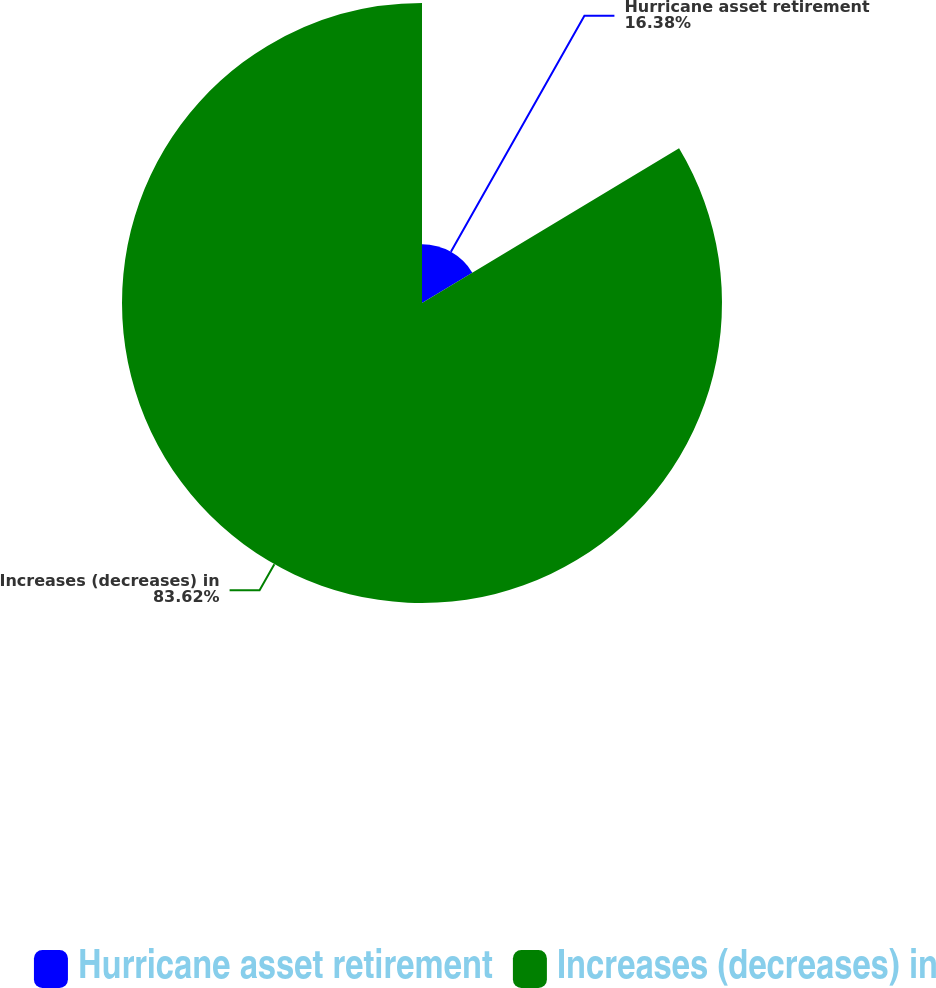Convert chart. <chart><loc_0><loc_0><loc_500><loc_500><pie_chart><fcel>Hurricane asset retirement<fcel>Increases (decreases) in<nl><fcel>16.38%<fcel>83.62%<nl></chart> 